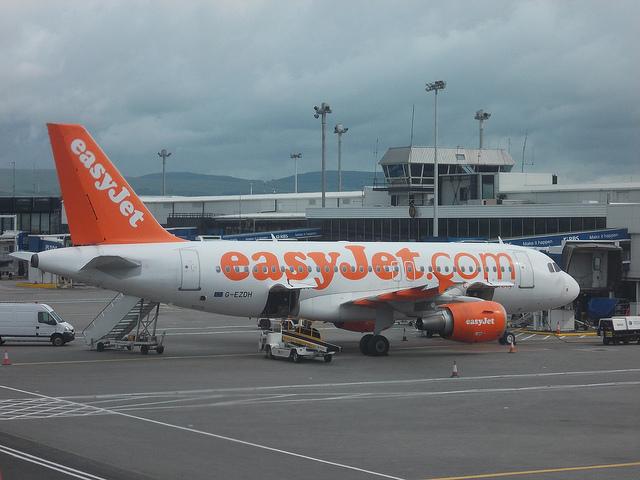Where is the plane?
Answer briefly. Airport. Which airline is this?
Give a very brief answer. Easyjet. What color is the emblem on the tail?
Short answer required. White. What is the name of this jet?
Short answer required. Easyjet. What airline owns the plane?
Quick response, please. Easyjet. What is the main color of the fuselage?
Keep it brief. White. 